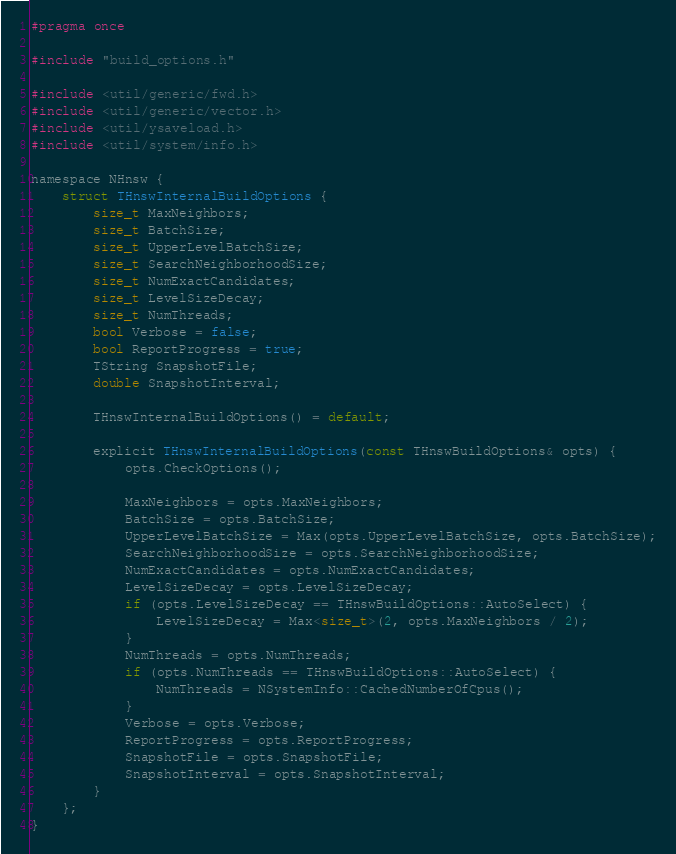Convert code to text. <code><loc_0><loc_0><loc_500><loc_500><_C_>#pragma once

#include "build_options.h"

#include <util/generic/fwd.h>
#include <util/generic/vector.h>
#include <util/ysaveload.h>
#include <util/system/info.h>

namespace NHnsw {
    struct THnswInternalBuildOptions {
        size_t MaxNeighbors;
        size_t BatchSize;
        size_t UpperLevelBatchSize;
        size_t SearchNeighborhoodSize;
        size_t NumExactCandidates;
        size_t LevelSizeDecay;
        size_t NumThreads;
        bool Verbose = false;
        bool ReportProgress = true;
        TString SnapshotFile;
        double SnapshotInterval;

        THnswInternalBuildOptions() = default;

        explicit THnswInternalBuildOptions(const THnswBuildOptions& opts) {
            opts.CheckOptions();

            MaxNeighbors = opts.MaxNeighbors;
            BatchSize = opts.BatchSize;
            UpperLevelBatchSize = Max(opts.UpperLevelBatchSize, opts.BatchSize);
            SearchNeighborhoodSize = opts.SearchNeighborhoodSize;
            NumExactCandidates = opts.NumExactCandidates;
            LevelSizeDecay = opts.LevelSizeDecay;
            if (opts.LevelSizeDecay == THnswBuildOptions::AutoSelect) {
                LevelSizeDecay = Max<size_t>(2, opts.MaxNeighbors / 2);
            }
            NumThreads = opts.NumThreads;
            if (opts.NumThreads == THnswBuildOptions::AutoSelect) {
                NumThreads = NSystemInfo::CachedNumberOfCpus();
            }
            Verbose = opts.Verbose;
            ReportProgress = opts.ReportProgress;
            SnapshotFile = opts.SnapshotFile;
            SnapshotInterval = opts.SnapshotInterval;
        }
    };
}
</code> 